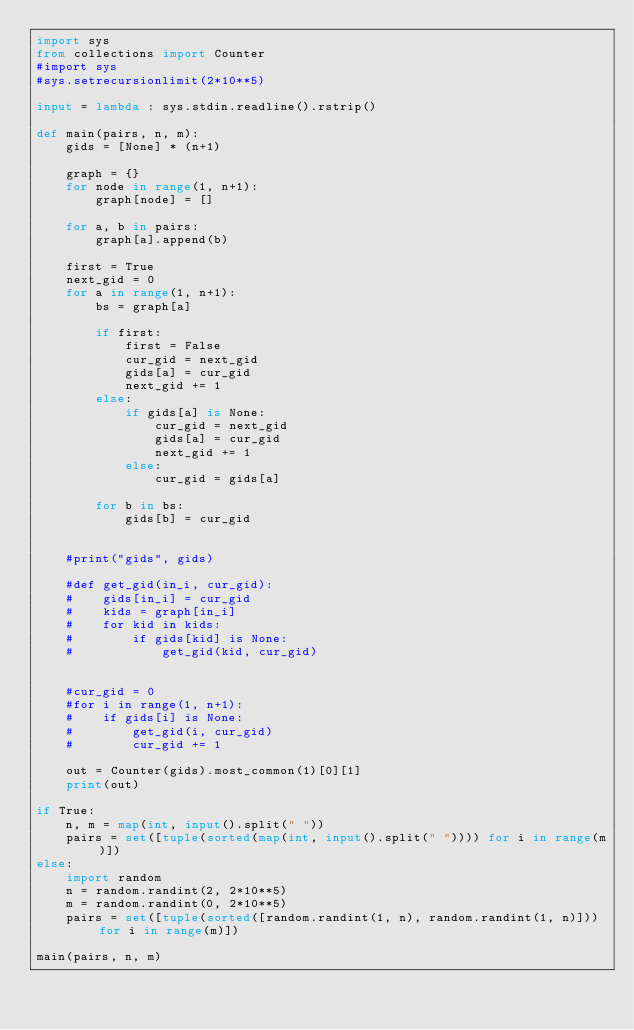Convert code to text. <code><loc_0><loc_0><loc_500><loc_500><_Python_>import sys
from collections import Counter
#import sys
#sys.setrecursionlimit(2*10**5)

input = lambda : sys.stdin.readline().rstrip()

def main(pairs, n, m):
    gids = [None] * (n+1)

    graph = {}
    for node in range(1, n+1):
        graph[node] = []

    for a, b in pairs:
        graph[a].append(b)

    first = True
    next_gid = 0
    for a in range(1, n+1):
        bs = graph[a]

        if first:
            first = False
            cur_gid = next_gid
            gids[a] = cur_gid
            next_gid += 1
        else:
            if gids[a] is None:
                cur_gid = next_gid
                gids[a] = cur_gid
                next_gid += 1
            else:
                cur_gid = gids[a]

        for b in bs:
            gids[b] = cur_gid


    #print("gids", gids)

    #def get_gid(in_i, cur_gid):
    #    gids[in_i] = cur_gid
    #    kids = graph[in_i]
    #    for kid in kids:
    #        if gids[kid] is None:
    #            get_gid(kid, cur_gid)


    #cur_gid = 0
    #for i in range(1, n+1):
    #    if gids[i] is None:
    #        get_gid(i, cur_gid)
    #        cur_gid += 1

    out = Counter(gids).most_common(1)[0][1]
    print(out)

if True:
    n, m = map(int, input().split(" "))
    pairs = set([tuple(sorted(map(int, input().split(" ")))) for i in range(m)])
else:
    import random
    n = random.randint(2, 2*10**5)
    m = random.randint(0, 2*10**5)
    pairs = set([tuple(sorted([random.randint(1, n), random.randint(1, n)])) for i in range(m)])

main(pairs, n, m)</code> 